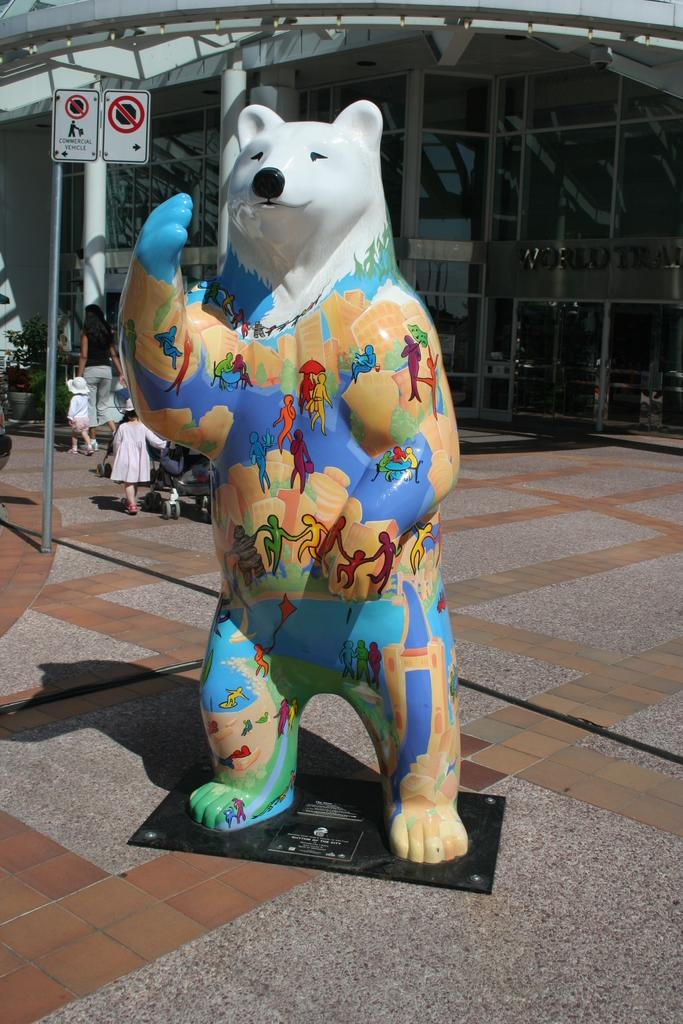What is the main subject in the image? There is a bear statue in the image. Are there any other people or objects near the bear statue? Yes, there are other persons behind the bear statue. What can be seen in the background of the image? There is a building in the background of the image. What type of knowledge is being shared among the persons in the image? There is no indication in the image that any knowledge is being shared among the persons. 